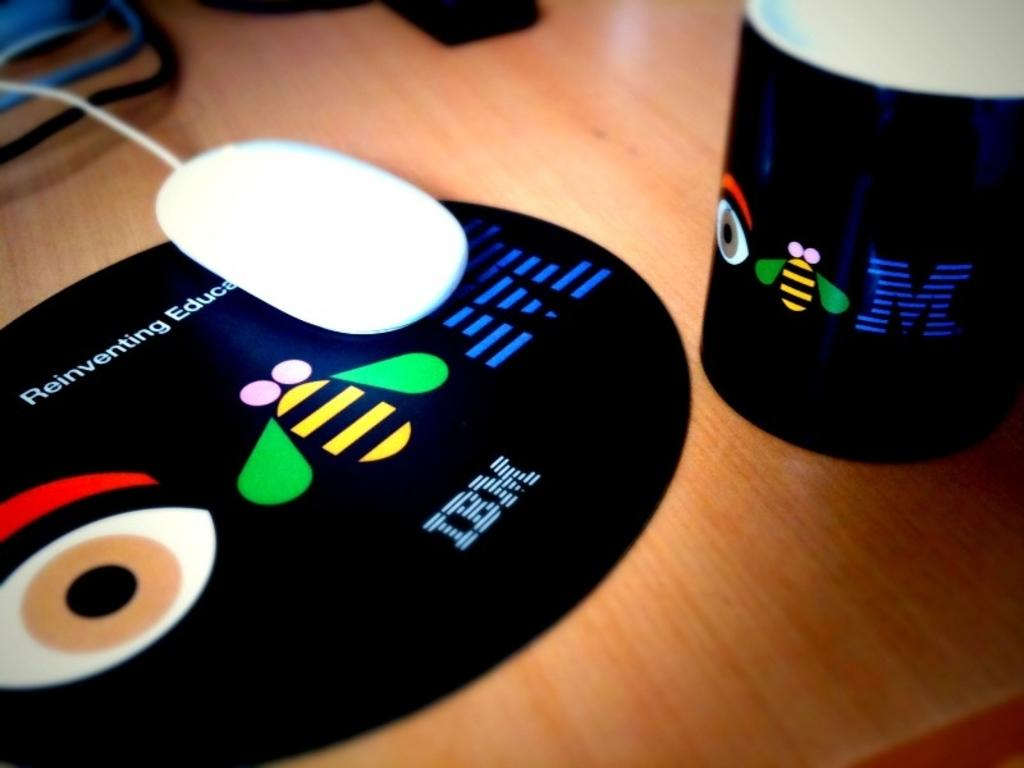<image>
Render a clear and concise summary of the photo. An IBM mousepad and mug sitting on a wooden table. 